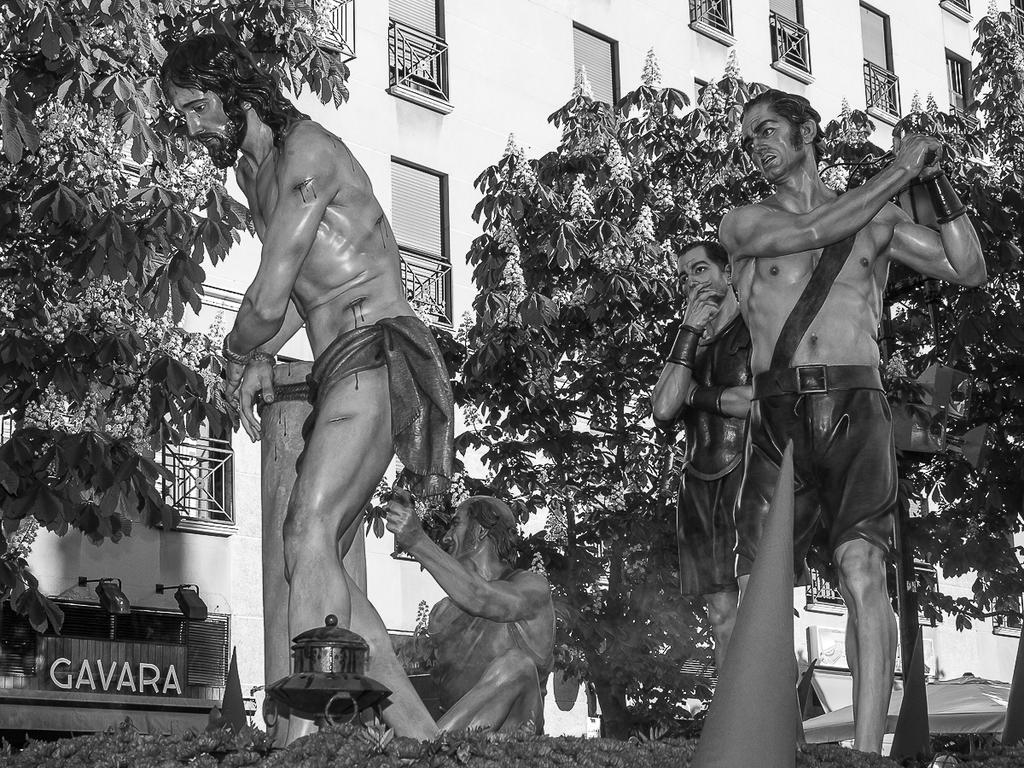What is the color scheme of the image? The image is black and white. What can be seen in the background of the image? There is a building in the background of the image. What type of objects are present in the image? There are statues, letter boards, lights, trees, and other objects present in the image. How does the image depict the level of pollution in the area? The image does not depict the level of pollution in the area, as it is a black and white image with no visible indicators of pollution. Can you tell me what type of suit the person in the image is wearing? There is no person present in the image, so it is not possible to determine what type of suit they might be wearing. 